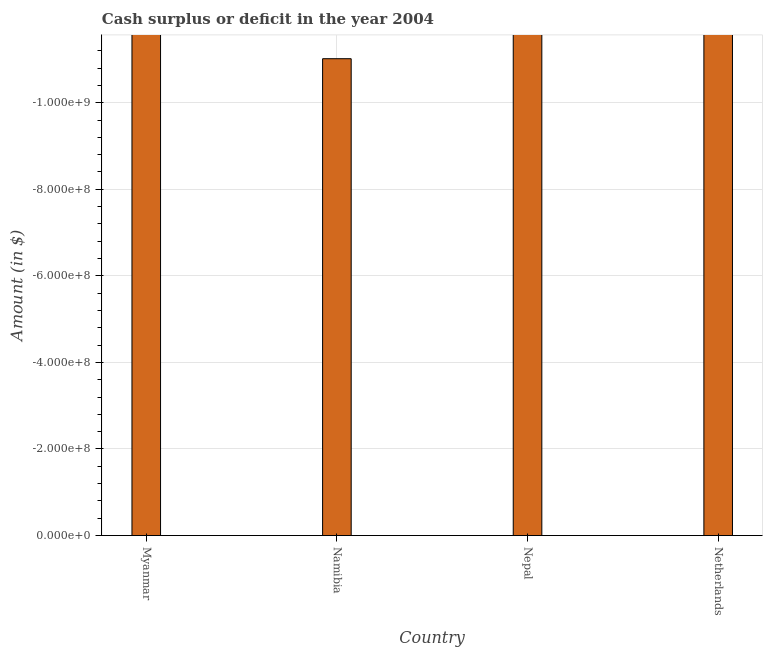What is the title of the graph?
Provide a short and direct response. Cash surplus or deficit in the year 2004. What is the label or title of the Y-axis?
Keep it short and to the point. Amount (in $). What is the average cash surplus or deficit per country?
Your answer should be compact. 0. What is the median cash surplus or deficit?
Provide a short and direct response. 0. In how many countries, is the cash surplus or deficit greater than -600000000 $?
Your answer should be compact. 0. How many bars are there?
Give a very brief answer. 0. What is the difference between two consecutive major ticks on the Y-axis?
Offer a very short reply. 2.00e+08. Are the values on the major ticks of Y-axis written in scientific E-notation?
Offer a very short reply. Yes. What is the Amount (in $) in Myanmar?
Your answer should be very brief. 0. What is the Amount (in $) of Namibia?
Make the answer very short. 0. 